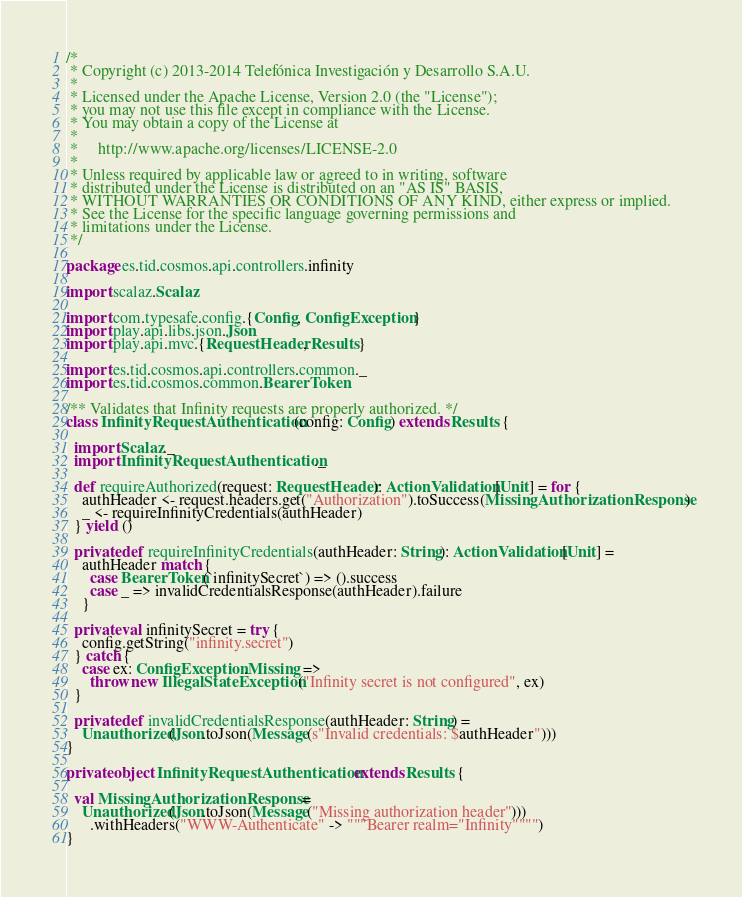Convert code to text. <code><loc_0><loc_0><loc_500><loc_500><_Scala_>/*
 * Copyright (c) 2013-2014 Telefónica Investigación y Desarrollo S.A.U.
 *
 * Licensed under the Apache License, Version 2.0 (the "License");
 * you may not use this file except in compliance with the License.
 * You may obtain a copy of the License at
 *
 *     http://www.apache.org/licenses/LICENSE-2.0
 *
 * Unless required by applicable law or agreed to in writing, software
 * distributed under the License is distributed on an "AS IS" BASIS,
 * WITHOUT WARRANTIES OR CONDITIONS OF ANY KIND, either express or implied.
 * See the License for the specific language governing permissions and
 * limitations under the License.
 */

package es.tid.cosmos.api.controllers.infinity

import scalaz.Scalaz

import com.typesafe.config.{Config, ConfigException}
import play.api.libs.json.Json
import play.api.mvc.{RequestHeader, Results}

import es.tid.cosmos.api.controllers.common._
import es.tid.cosmos.common.BearerToken

/** Validates that Infinity requests are properly authorized. */
class InfinityRequestAuthentication(config: Config) extends Results {

  import Scalaz._
  import InfinityRequestAuthentication._

  def requireAuthorized(request: RequestHeader): ActionValidation[Unit] = for {
    authHeader <- request.headers.get("Authorization").toSuccess(MissingAuthorizationResponse)
    _ <- requireInfinityCredentials(authHeader)
  } yield ()

  private def requireInfinityCredentials(authHeader: String): ActionValidation[Unit] =
    authHeader match {
      case BearerToken(`infinitySecret`) => ().success
      case _ => invalidCredentialsResponse(authHeader).failure
    }

  private val infinitySecret = try {
    config.getString("infinity.secret")
  } catch {
    case ex: ConfigException.Missing =>
      throw new IllegalStateException("Infinity secret is not configured", ex)
  }

  private def invalidCredentialsResponse(authHeader: String) =
    Unauthorized(Json.toJson(Message(s"Invalid credentials: $authHeader")))
}

private object InfinityRequestAuthentication extends Results {

  val MissingAuthorizationResponse =
    Unauthorized(Json.toJson(Message("Missing authorization header")))
      .withHeaders("WWW-Authenticate" -> """Bearer realm="Infinity"""")
}
</code> 